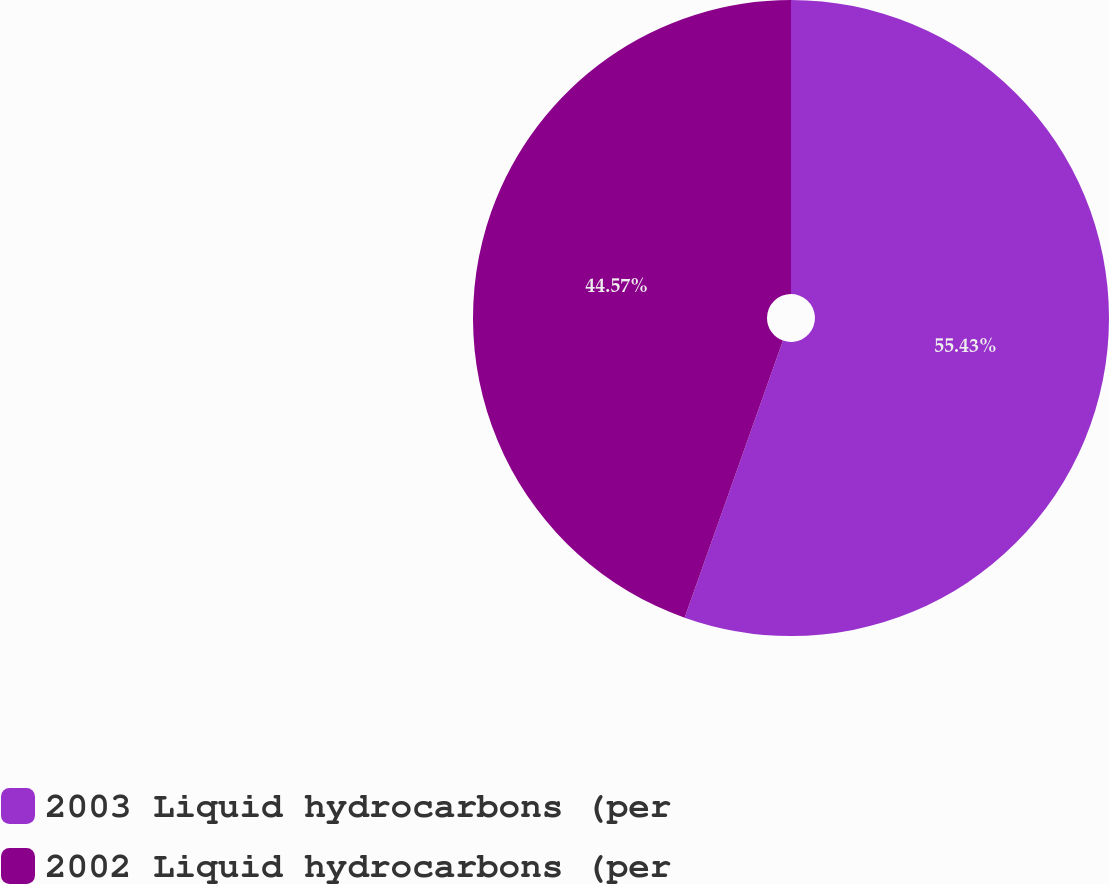Convert chart. <chart><loc_0><loc_0><loc_500><loc_500><pie_chart><fcel>2003 Liquid hydrocarbons (per<fcel>2002 Liquid hydrocarbons (per<nl><fcel>55.43%<fcel>44.57%<nl></chart> 